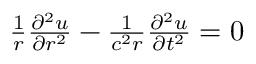<formula> <loc_0><loc_0><loc_500><loc_500>\begin{array} { r } { \frac { 1 } { r } \frac { \partial ^ { 2 } u } { \partial r ^ { 2 } } - \frac { 1 } { c ^ { 2 } r } \frac { \partial ^ { 2 } u } { \partial t ^ { 2 } } = 0 } \end{array}</formula> 